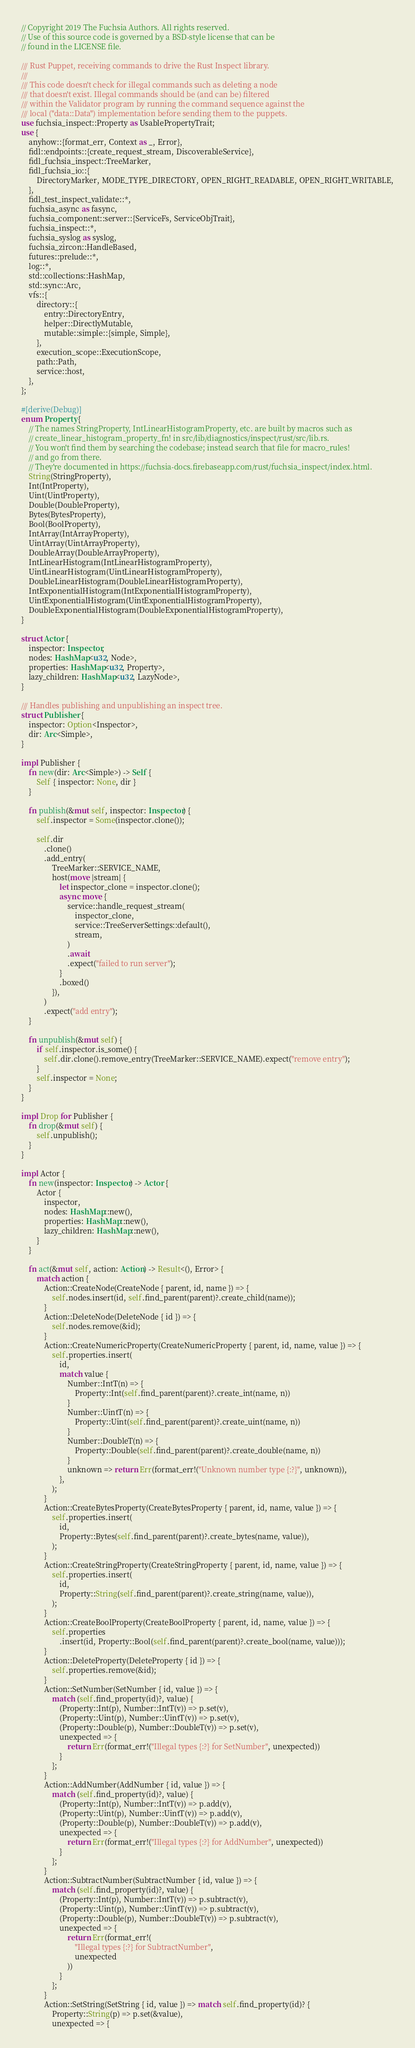<code> <loc_0><loc_0><loc_500><loc_500><_Rust_>// Copyright 2019 The Fuchsia Authors. All rights reserved.
// Use of this source code is governed by a BSD-style license that can be
// found in the LICENSE file.

/// Rust Puppet, receiving commands to drive the Rust Inspect library.
///
/// This code doesn't check for illegal commands such as deleting a node
/// that doesn't exist. Illegal commands should be (and can be) filtered
/// within the Validator program by running the command sequence against the
/// local ("data::Data") implementation before sending them to the puppets.
use fuchsia_inspect::Property as UsablePropertyTrait;
use {
    anyhow::{format_err, Context as _, Error},
    fidl::endpoints::{create_request_stream, DiscoverableService},
    fidl_fuchsia_inspect::TreeMarker,
    fidl_fuchsia_io::{
        DirectoryMarker, MODE_TYPE_DIRECTORY, OPEN_RIGHT_READABLE, OPEN_RIGHT_WRITABLE,
    },
    fidl_test_inspect_validate::*,
    fuchsia_async as fasync,
    fuchsia_component::server::{ServiceFs, ServiceObjTrait},
    fuchsia_inspect::*,
    fuchsia_syslog as syslog,
    fuchsia_zircon::HandleBased,
    futures::prelude::*,
    log::*,
    std::collections::HashMap,
    std::sync::Arc,
    vfs::{
        directory::{
            entry::DirectoryEntry,
            helper::DirectlyMutable,
            mutable::simple::{simple, Simple},
        },
        execution_scope::ExecutionScope,
        path::Path,
        service::host,
    },
};

#[derive(Debug)]
enum Property {
    // The names StringProperty, IntLinearHistogramProperty, etc. are built by macros such as
    // create_linear_histogram_property_fn! in src/lib/diagnostics/inspect/rust/src/lib.rs.
    // You won't find them by searching the codebase; instead search that file for macro_rules!
    // and go from there.
    // They're documented in https://fuchsia-docs.firebaseapp.com/rust/fuchsia_inspect/index.html.
    String(StringProperty),
    Int(IntProperty),
    Uint(UintProperty),
    Double(DoubleProperty),
    Bytes(BytesProperty),
    Bool(BoolProperty),
    IntArray(IntArrayProperty),
    UintArray(UintArrayProperty),
    DoubleArray(DoubleArrayProperty),
    IntLinearHistogram(IntLinearHistogramProperty),
    UintLinearHistogram(UintLinearHistogramProperty),
    DoubleLinearHistogram(DoubleLinearHistogramProperty),
    IntExponentialHistogram(IntExponentialHistogramProperty),
    UintExponentialHistogram(UintExponentialHistogramProperty),
    DoubleExponentialHistogram(DoubleExponentialHistogramProperty),
}

struct Actor {
    inspector: Inspector,
    nodes: HashMap<u32, Node>,
    properties: HashMap<u32, Property>,
    lazy_children: HashMap<u32, LazyNode>,
}

/// Handles publishing and unpublishing an inspect tree.
struct Publisher {
    inspector: Option<Inspector>,
    dir: Arc<Simple>,
}

impl Publisher {
    fn new(dir: Arc<Simple>) -> Self {
        Self { inspector: None, dir }
    }

    fn publish(&mut self, inspector: Inspector) {
        self.inspector = Some(inspector.clone());

        self.dir
            .clone()
            .add_entry(
                TreeMarker::SERVICE_NAME,
                host(move |stream| {
                    let inspector_clone = inspector.clone();
                    async move {
                        service::handle_request_stream(
                            inspector_clone,
                            service::TreeServerSettings::default(),
                            stream,
                        )
                        .await
                        .expect("failed to run server");
                    }
                    .boxed()
                }),
            )
            .expect("add entry");
    }

    fn unpublish(&mut self) {
        if self.inspector.is_some() {
            self.dir.clone().remove_entry(TreeMarker::SERVICE_NAME).expect("remove entry");
        }
        self.inspector = None;
    }
}

impl Drop for Publisher {
    fn drop(&mut self) {
        self.unpublish();
    }
}

impl Actor {
    fn new(inspector: Inspector) -> Actor {
        Actor {
            inspector,
            nodes: HashMap::new(),
            properties: HashMap::new(),
            lazy_children: HashMap::new(),
        }
    }

    fn act(&mut self, action: Action) -> Result<(), Error> {
        match action {
            Action::CreateNode(CreateNode { parent, id, name }) => {
                self.nodes.insert(id, self.find_parent(parent)?.create_child(name));
            }
            Action::DeleteNode(DeleteNode { id }) => {
                self.nodes.remove(&id);
            }
            Action::CreateNumericProperty(CreateNumericProperty { parent, id, name, value }) => {
                self.properties.insert(
                    id,
                    match value {
                        Number::IntT(n) => {
                            Property::Int(self.find_parent(parent)?.create_int(name, n))
                        }
                        Number::UintT(n) => {
                            Property::Uint(self.find_parent(parent)?.create_uint(name, n))
                        }
                        Number::DoubleT(n) => {
                            Property::Double(self.find_parent(parent)?.create_double(name, n))
                        }
                        unknown => return Err(format_err!("Unknown number type {:?}", unknown)),
                    },
                );
            }
            Action::CreateBytesProperty(CreateBytesProperty { parent, id, name, value }) => {
                self.properties.insert(
                    id,
                    Property::Bytes(self.find_parent(parent)?.create_bytes(name, value)),
                );
            }
            Action::CreateStringProperty(CreateStringProperty { parent, id, name, value }) => {
                self.properties.insert(
                    id,
                    Property::String(self.find_parent(parent)?.create_string(name, value)),
                );
            }
            Action::CreateBoolProperty(CreateBoolProperty { parent, id, name, value }) => {
                self.properties
                    .insert(id, Property::Bool(self.find_parent(parent)?.create_bool(name, value)));
            }
            Action::DeleteProperty(DeleteProperty { id }) => {
                self.properties.remove(&id);
            }
            Action::SetNumber(SetNumber { id, value }) => {
                match (self.find_property(id)?, value) {
                    (Property::Int(p), Number::IntT(v)) => p.set(v),
                    (Property::Uint(p), Number::UintT(v)) => p.set(v),
                    (Property::Double(p), Number::DoubleT(v)) => p.set(v),
                    unexpected => {
                        return Err(format_err!("Illegal types {:?} for SetNumber", unexpected))
                    }
                };
            }
            Action::AddNumber(AddNumber { id, value }) => {
                match (self.find_property(id)?, value) {
                    (Property::Int(p), Number::IntT(v)) => p.add(v),
                    (Property::Uint(p), Number::UintT(v)) => p.add(v),
                    (Property::Double(p), Number::DoubleT(v)) => p.add(v),
                    unexpected => {
                        return Err(format_err!("Illegal types {:?} for AddNumber", unexpected))
                    }
                };
            }
            Action::SubtractNumber(SubtractNumber { id, value }) => {
                match (self.find_property(id)?, value) {
                    (Property::Int(p), Number::IntT(v)) => p.subtract(v),
                    (Property::Uint(p), Number::UintT(v)) => p.subtract(v),
                    (Property::Double(p), Number::DoubleT(v)) => p.subtract(v),
                    unexpected => {
                        return Err(format_err!(
                            "Illegal types {:?} for SubtractNumber",
                            unexpected
                        ))
                    }
                };
            }
            Action::SetString(SetString { id, value }) => match self.find_property(id)? {
                Property::String(p) => p.set(&value),
                unexpected => {</code> 